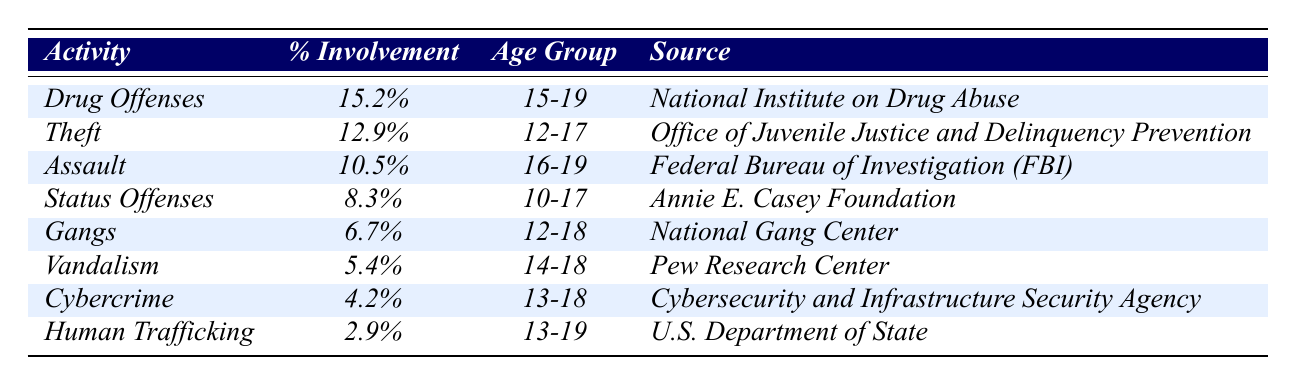What is the percentage involvement in drug offenses among youth aged 15-19? According to the table, the percentage involvement in drug offenses for the age group 15-19 is specifically listed under that row, which shows 15.2%.
Answer: 15.2% Which illegal activity has the highest percentage involvement among youth? By reviewing the table, the illegal activity with the highest percentage involvement is drug offenses, with 15.2%.
Answer: Drug Offenses Is there any activity where the youth involvement is above 10%? Looking at the table, we can see that drug offenses (15.2%), theft (12.9%), and assault (10.5%) are all activities with youth involvement above 10%.
Answer: Yes How many different activities are listed in the table? The table lists a total of 8 different activities related to youth involvement in illegal activities.
Answer: 8 What is the average percentage involvement of youth in vandalism, cybercrime, and human trafficking? First, we find the percentages for each: vandalism is 5.4%, cybercrime is 4.2%, and human trafficking is 2.9%. Adding these gives 5.4 + 4.2 + 2.9 = 12.5%. Then, to find the average, we divide by 3, resulting in 12.5 / 3 = 4.17%.
Answer: 4.17% What is the difference in percentage involvement between theft and gangs? The percentage for theft is 12.9%, while for gangs it is 6.7%. The difference is calculated by subtracting the percentage for gangs from theft: 12.9 - 6.7 = 6.2%.
Answer: 6.2% Are there any activities that involve youth aged 10-17? Yes, by examining the age groups associated with each illegal activity, both status offenses (ages 10-17) and theft (ages 12-17) involve youth in that age range.
Answer: Yes What is the least common illegal activity among youth based on the table? The least common illegal activity is human trafficking, which has the lowest percentage of involvement at 2.9%.
Answer: Human Trafficking Which age group has the highest involvement in theft? The age group associated with theft, as per the table, is 12-17, which indicates that this group has the highest involvement in theft compared to other activities.
Answer: 12-17 Is the percentage involvement in cybercrime greater than that in vandalism? In the table, cybercrime has 4.2% involvement, while vandalism has 5.4%. Since 4.2% is less than 5.4%, the statement is false.
Answer: No What percentage of youth are involved in status offenses compared to gang involvement? Status offenses have an involvement of 8.3%, while gang involvement is at 6.7%. Comparing these two percentages, 8.3% is greater than 6.7%.
Answer: 8.3% and 6.7% respectively 